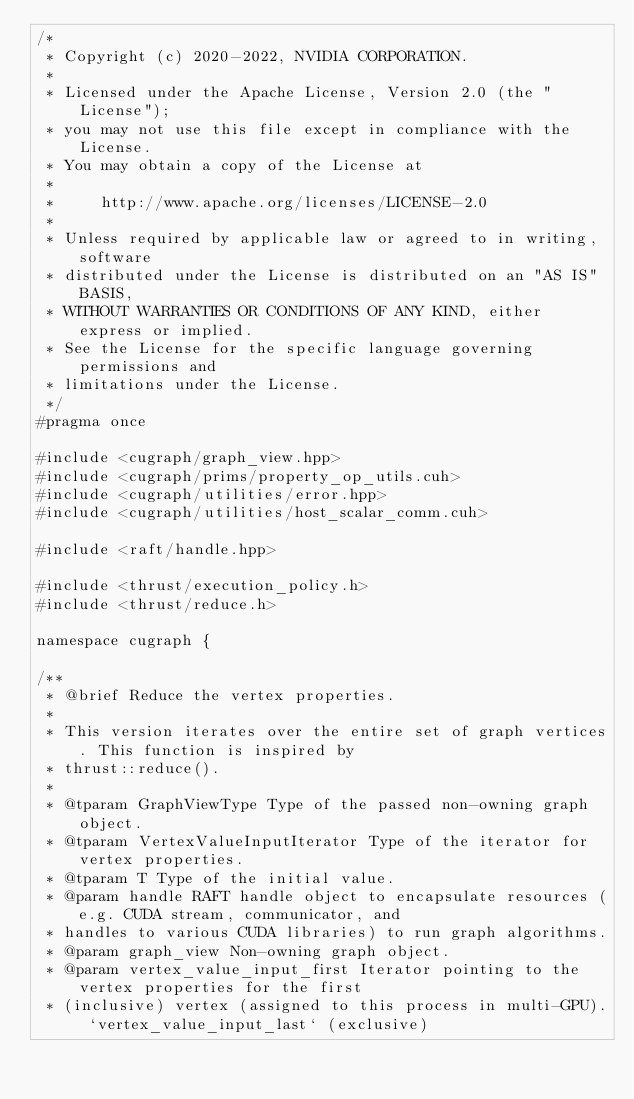Convert code to text. <code><loc_0><loc_0><loc_500><loc_500><_Cuda_>/*
 * Copyright (c) 2020-2022, NVIDIA CORPORATION.
 *
 * Licensed under the Apache License, Version 2.0 (the "License");
 * you may not use this file except in compliance with the License.
 * You may obtain a copy of the License at
 *
 *     http://www.apache.org/licenses/LICENSE-2.0
 *
 * Unless required by applicable law or agreed to in writing, software
 * distributed under the License is distributed on an "AS IS" BASIS,
 * WITHOUT WARRANTIES OR CONDITIONS OF ANY KIND, either express or implied.
 * See the License for the specific language governing permissions and
 * limitations under the License.
 */
#pragma once

#include <cugraph/graph_view.hpp>
#include <cugraph/prims/property_op_utils.cuh>
#include <cugraph/utilities/error.hpp>
#include <cugraph/utilities/host_scalar_comm.cuh>

#include <raft/handle.hpp>

#include <thrust/execution_policy.h>
#include <thrust/reduce.h>

namespace cugraph {

/**
 * @brief Reduce the vertex properties.
 *
 * This version iterates over the entire set of graph vertices. This function is inspired by
 * thrust::reduce().
 *
 * @tparam GraphViewType Type of the passed non-owning graph object.
 * @tparam VertexValueInputIterator Type of the iterator for vertex properties.
 * @tparam T Type of the initial value.
 * @param handle RAFT handle object to encapsulate resources (e.g. CUDA stream, communicator, and
 * handles to various CUDA libraries) to run graph algorithms.
 * @param graph_view Non-owning graph object.
 * @param vertex_value_input_first Iterator pointing to the vertex properties for the first
 * (inclusive) vertex (assigned to this process in multi-GPU). `vertex_value_input_last` (exclusive)</code> 